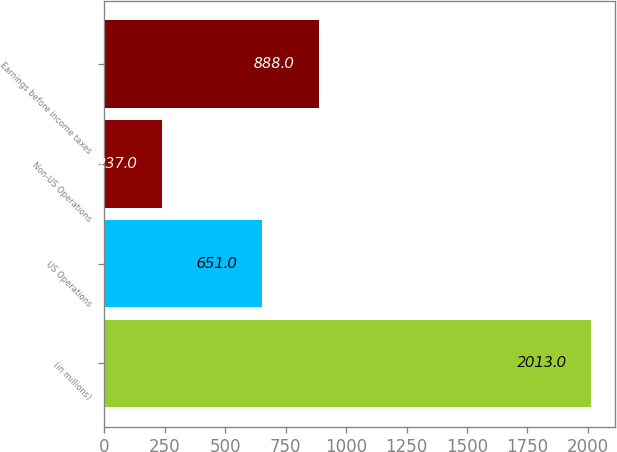Convert chart to OTSL. <chart><loc_0><loc_0><loc_500><loc_500><bar_chart><fcel>(in millions)<fcel>US Operations<fcel>Non-US Operations<fcel>Earnings before income taxes<nl><fcel>2013<fcel>651<fcel>237<fcel>888<nl></chart> 